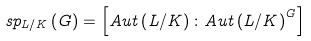Convert formula to latex. <formula><loc_0><loc_0><loc_500><loc_500>s p _ { L / K } \left ( G \right ) = \left [ A u t \left ( L / K \right ) \colon A u t \left ( L / K \right ) ^ { G } \right ]</formula> 